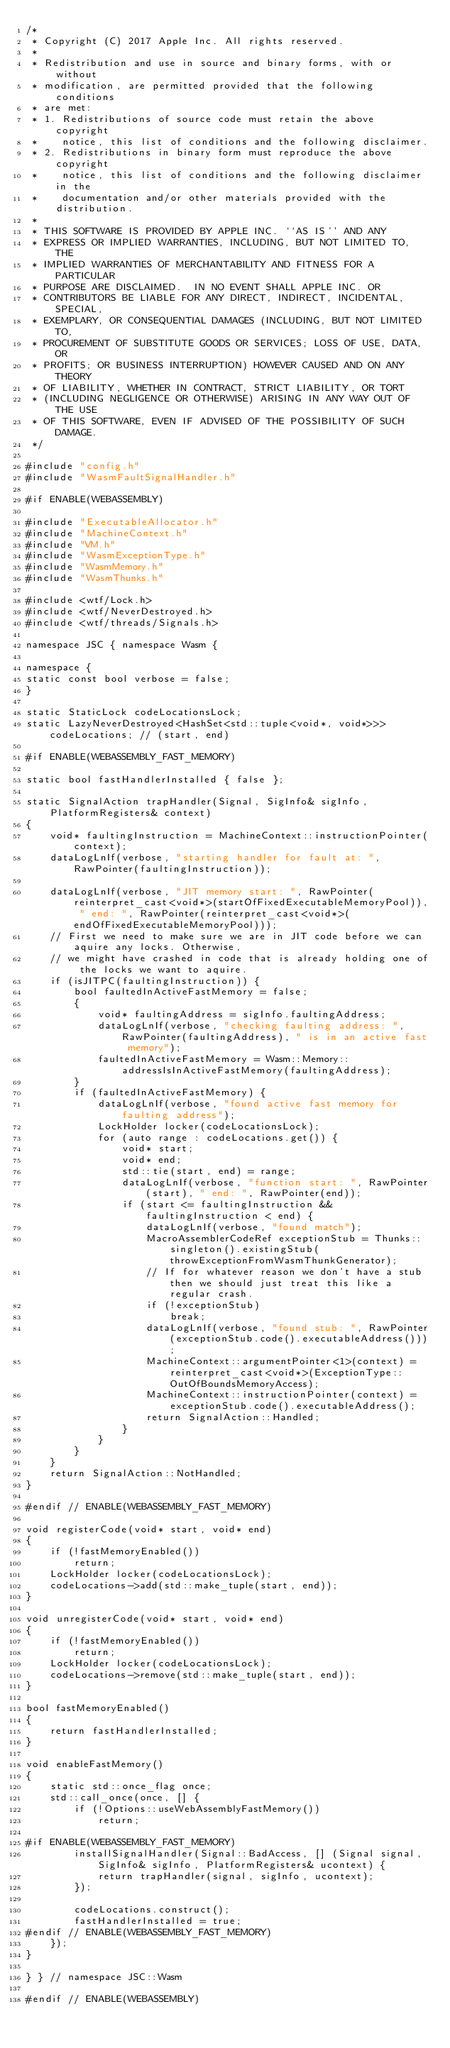<code> <loc_0><loc_0><loc_500><loc_500><_C++_>/*
 * Copyright (C) 2017 Apple Inc. All rights reserved.
 *
 * Redistribution and use in source and binary forms, with or without
 * modification, are permitted provided that the following conditions
 * are met:
 * 1. Redistributions of source code must retain the above copyright
 *    notice, this list of conditions and the following disclaimer.
 * 2. Redistributions in binary form must reproduce the above copyright
 *    notice, this list of conditions and the following disclaimer in the
 *    documentation and/or other materials provided with the distribution.
 *
 * THIS SOFTWARE IS PROVIDED BY APPLE INC. ``AS IS'' AND ANY
 * EXPRESS OR IMPLIED WARRANTIES, INCLUDING, BUT NOT LIMITED TO, THE
 * IMPLIED WARRANTIES OF MERCHANTABILITY AND FITNESS FOR A PARTICULAR
 * PURPOSE ARE DISCLAIMED.  IN NO EVENT SHALL APPLE INC. OR
 * CONTRIBUTORS BE LIABLE FOR ANY DIRECT, INDIRECT, INCIDENTAL, SPECIAL,
 * EXEMPLARY, OR CONSEQUENTIAL DAMAGES (INCLUDING, BUT NOT LIMITED TO,
 * PROCUREMENT OF SUBSTITUTE GOODS OR SERVICES; LOSS OF USE, DATA, OR
 * PROFITS; OR BUSINESS INTERRUPTION) HOWEVER CAUSED AND ON ANY THEORY
 * OF LIABILITY, WHETHER IN CONTRACT, STRICT LIABILITY, OR TORT
 * (INCLUDING NEGLIGENCE OR OTHERWISE) ARISING IN ANY WAY OUT OF THE USE
 * OF THIS SOFTWARE, EVEN IF ADVISED OF THE POSSIBILITY OF SUCH DAMAGE.
 */

#include "config.h"
#include "WasmFaultSignalHandler.h"

#if ENABLE(WEBASSEMBLY)

#include "ExecutableAllocator.h"
#include "MachineContext.h"
#include "VM.h"
#include "WasmExceptionType.h"
#include "WasmMemory.h"
#include "WasmThunks.h"

#include <wtf/Lock.h>
#include <wtf/NeverDestroyed.h>
#include <wtf/threads/Signals.h>

namespace JSC { namespace Wasm {

namespace {
static const bool verbose = false;
}

static StaticLock codeLocationsLock;
static LazyNeverDestroyed<HashSet<std::tuple<void*, void*>>> codeLocations; // (start, end)

#if ENABLE(WEBASSEMBLY_FAST_MEMORY)

static bool fastHandlerInstalled { false };

static SignalAction trapHandler(Signal, SigInfo& sigInfo, PlatformRegisters& context)
{
    void* faultingInstruction = MachineContext::instructionPointer(context);
    dataLogLnIf(verbose, "starting handler for fault at: ", RawPointer(faultingInstruction));

    dataLogLnIf(verbose, "JIT memory start: ", RawPointer(reinterpret_cast<void*>(startOfFixedExecutableMemoryPool)), " end: ", RawPointer(reinterpret_cast<void*>(endOfFixedExecutableMemoryPool)));
    // First we need to make sure we are in JIT code before we can aquire any locks. Otherwise,
    // we might have crashed in code that is already holding one of the locks we want to aquire.
    if (isJITPC(faultingInstruction)) {
        bool faultedInActiveFastMemory = false;
        {
            void* faultingAddress = sigInfo.faultingAddress;
            dataLogLnIf(verbose, "checking faulting address: ", RawPointer(faultingAddress), " is in an active fast memory");
            faultedInActiveFastMemory = Wasm::Memory::addressIsInActiveFastMemory(faultingAddress);
        }
        if (faultedInActiveFastMemory) {
            dataLogLnIf(verbose, "found active fast memory for faulting address");
            LockHolder locker(codeLocationsLock);
            for (auto range : codeLocations.get()) {
                void* start;
                void* end;
                std::tie(start, end) = range;
                dataLogLnIf(verbose, "function start: ", RawPointer(start), " end: ", RawPointer(end));
                if (start <= faultingInstruction && faultingInstruction < end) {
                    dataLogLnIf(verbose, "found match");
                    MacroAssemblerCodeRef exceptionStub = Thunks::singleton().existingStub(throwExceptionFromWasmThunkGenerator);
                    // If for whatever reason we don't have a stub then we should just treat this like a regular crash.
                    if (!exceptionStub)
                        break;
                    dataLogLnIf(verbose, "found stub: ", RawPointer(exceptionStub.code().executableAddress()));
                    MachineContext::argumentPointer<1>(context) = reinterpret_cast<void*>(ExceptionType::OutOfBoundsMemoryAccess);
                    MachineContext::instructionPointer(context) = exceptionStub.code().executableAddress();
                    return SignalAction::Handled;
                }
            }
        }
    }
    return SignalAction::NotHandled;
}

#endif // ENABLE(WEBASSEMBLY_FAST_MEMORY)

void registerCode(void* start, void* end)
{
    if (!fastMemoryEnabled())
        return;
    LockHolder locker(codeLocationsLock);
    codeLocations->add(std::make_tuple(start, end));
}

void unregisterCode(void* start, void* end)
{
    if (!fastMemoryEnabled())
        return;
    LockHolder locker(codeLocationsLock);
    codeLocations->remove(std::make_tuple(start, end));
}

bool fastMemoryEnabled()
{
    return fastHandlerInstalled;
}

void enableFastMemory()
{
    static std::once_flag once;
    std::call_once(once, [] {
        if (!Options::useWebAssemblyFastMemory())
            return;

#if ENABLE(WEBASSEMBLY_FAST_MEMORY)
        installSignalHandler(Signal::BadAccess, [] (Signal signal, SigInfo& sigInfo, PlatformRegisters& ucontext) {
            return trapHandler(signal, sigInfo, ucontext);
        });

        codeLocations.construct();
        fastHandlerInstalled = true;
#endif // ENABLE(WEBASSEMBLY_FAST_MEMORY)
    });
}
    
} } // namespace JSC::Wasm

#endif // ENABLE(WEBASSEMBLY)

</code> 